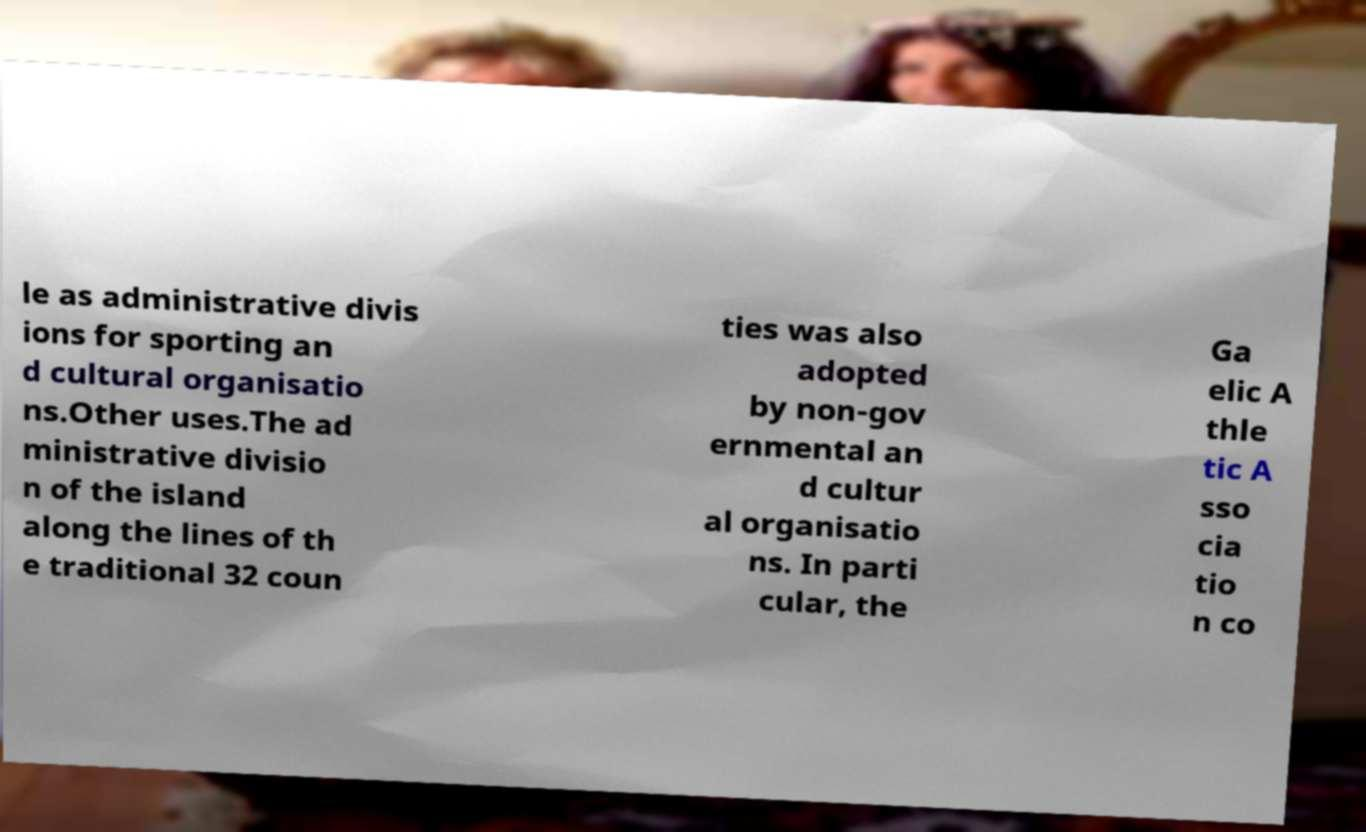Could you assist in decoding the text presented in this image and type it out clearly? le as administrative divis ions for sporting an d cultural organisatio ns.Other uses.The ad ministrative divisio n of the island along the lines of th e traditional 32 coun ties was also adopted by non-gov ernmental an d cultur al organisatio ns. In parti cular, the Ga elic A thle tic A sso cia tio n co 